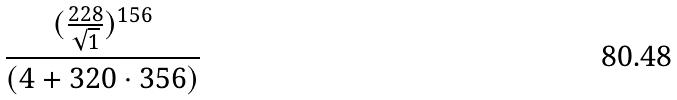<formula> <loc_0><loc_0><loc_500><loc_500>\frac { ( \frac { 2 2 8 } { \sqrt { 1 } } ) ^ { 1 5 6 } } { ( 4 + 3 2 0 \cdot 3 5 6 ) }</formula> 